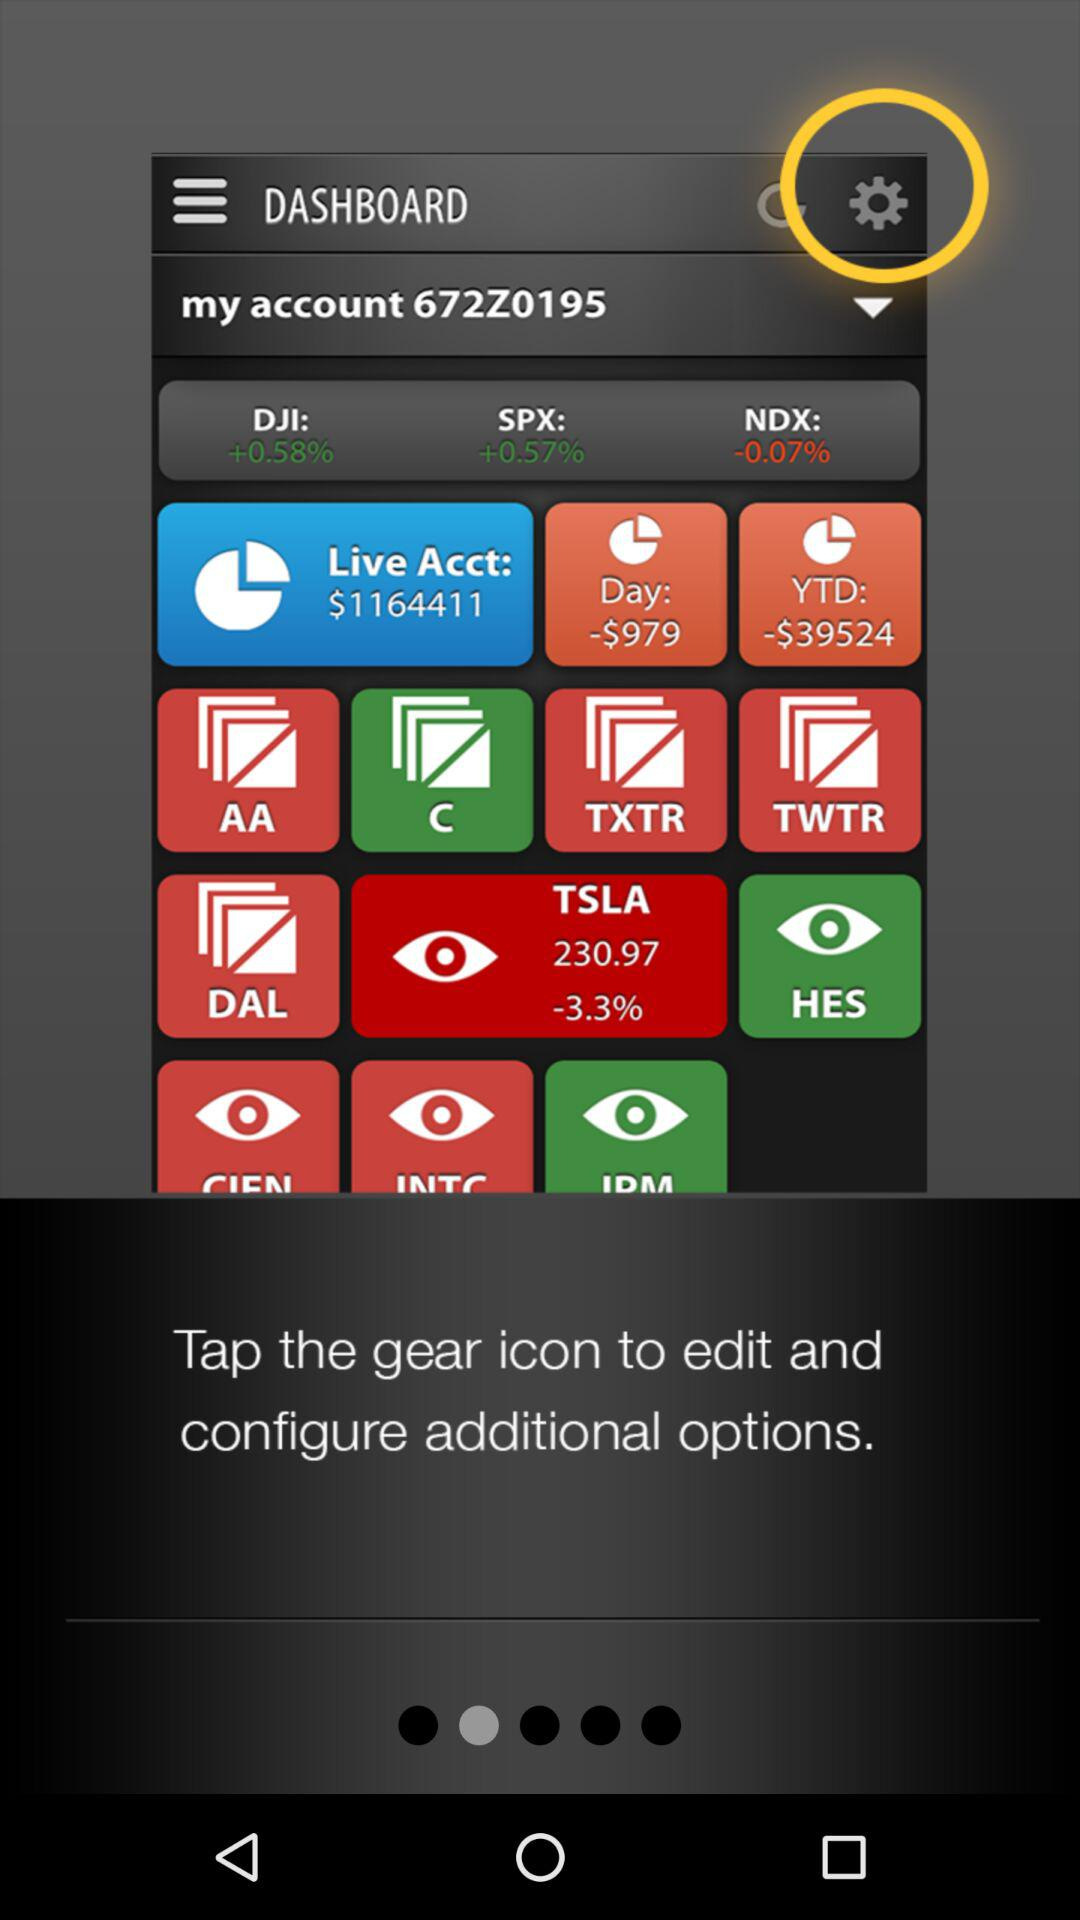How much more is the YTD loss than the day loss?
Answer the question using a single word or phrase. $38545 